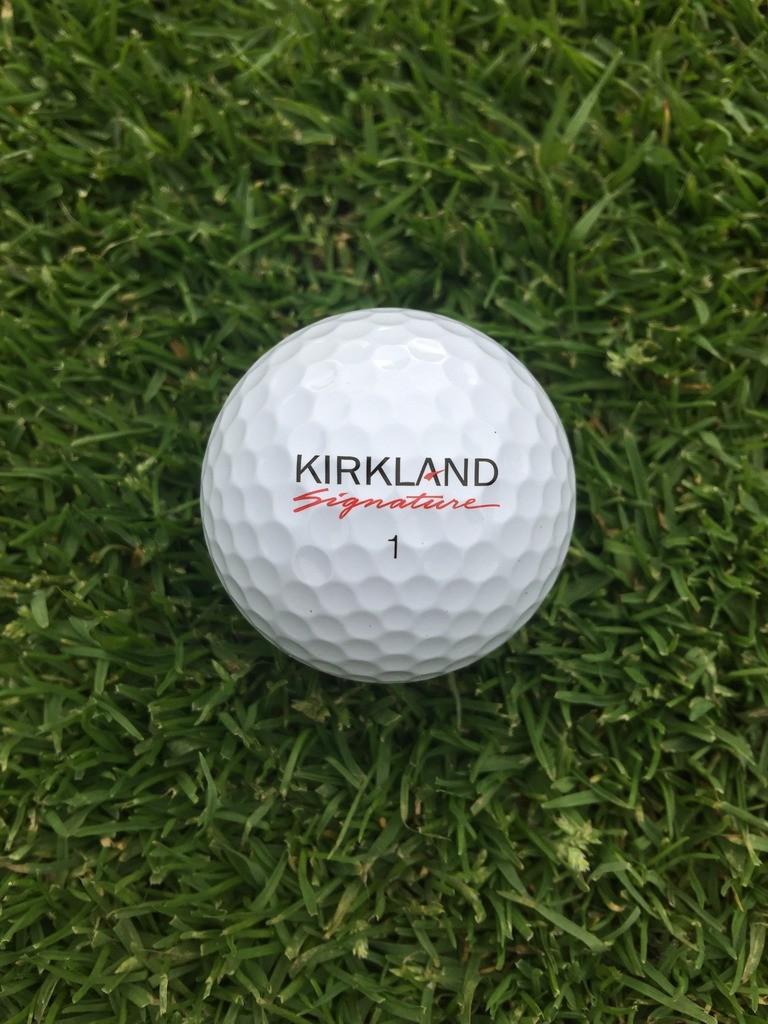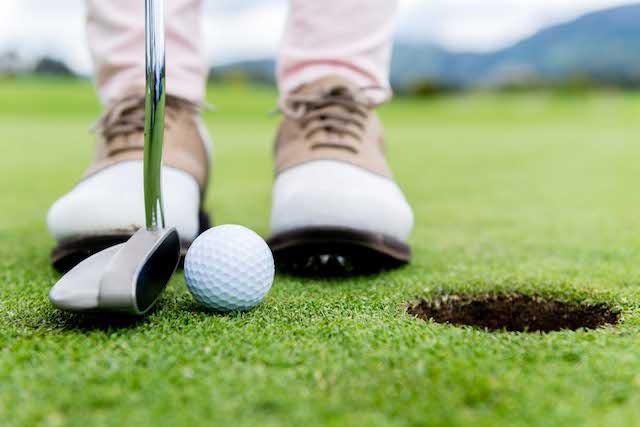The first image is the image on the left, the second image is the image on the right. Examine the images to the left and right. Is the description "An image shows a club right next to a golf ball." accurate? Answer yes or no. Yes. The first image is the image on the left, the second image is the image on the right. Analyze the images presented: Is the assertion "One of the images contain a golf ball right next to a golf club." valid? Answer yes or no. Yes. 